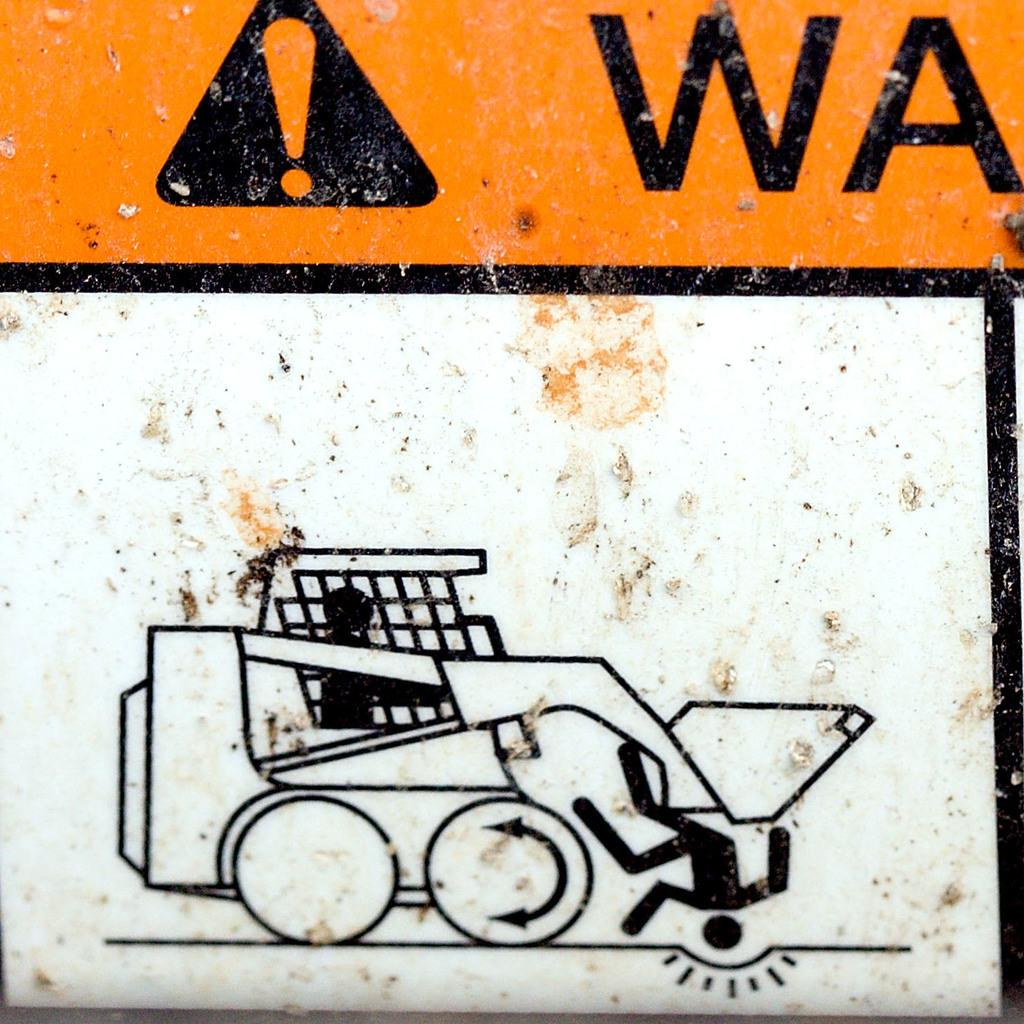What is the main object in the image? There is a board in the image. What colors are present on the board? The board is white, black, and orange in color. What can be seen on the board besides its colors? There is a symbol and a drawing on the board. How does the woman in the image react to the rainstorm? There is no woman or rainstorm present in the image; it only features a board with a symbol and a drawing. 